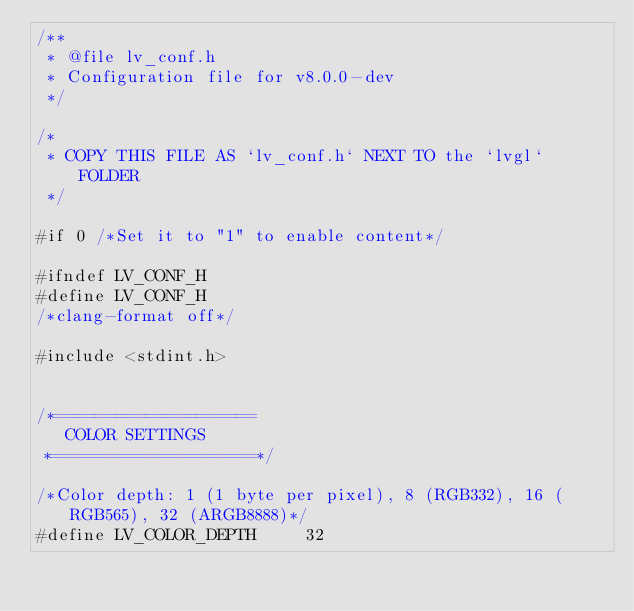Convert code to text. <code><loc_0><loc_0><loc_500><loc_500><_C_>/**
 * @file lv_conf.h
 * Configuration file for v8.0.0-dev
 */

/*
 * COPY THIS FILE AS `lv_conf.h` NEXT TO the `lvgl` FOLDER
 */

#if 0 /*Set it to "1" to enable content*/

#ifndef LV_CONF_H
#define LV_CONF_H
/*clang-format off*/

#include <stdint.h>


/*====================
   COLOR SETTINGS
 *====================*/

/*Color depth: 1 (1 byte per pixel), 8 (RGB332), 16 (RGB565), 32 (ARGB8888)*/
#define LV_COLOR_DEPTH     32
</code> 